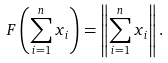<formula> <loc_0><loc_0><loc_500><loc_500>F \left ( \sum _ { i = 1 } ^ { n } x _ { i } \right ) = \left \| \sum _ { i = 1 } ^ { n } x _ { i } \right \| .</formula> 